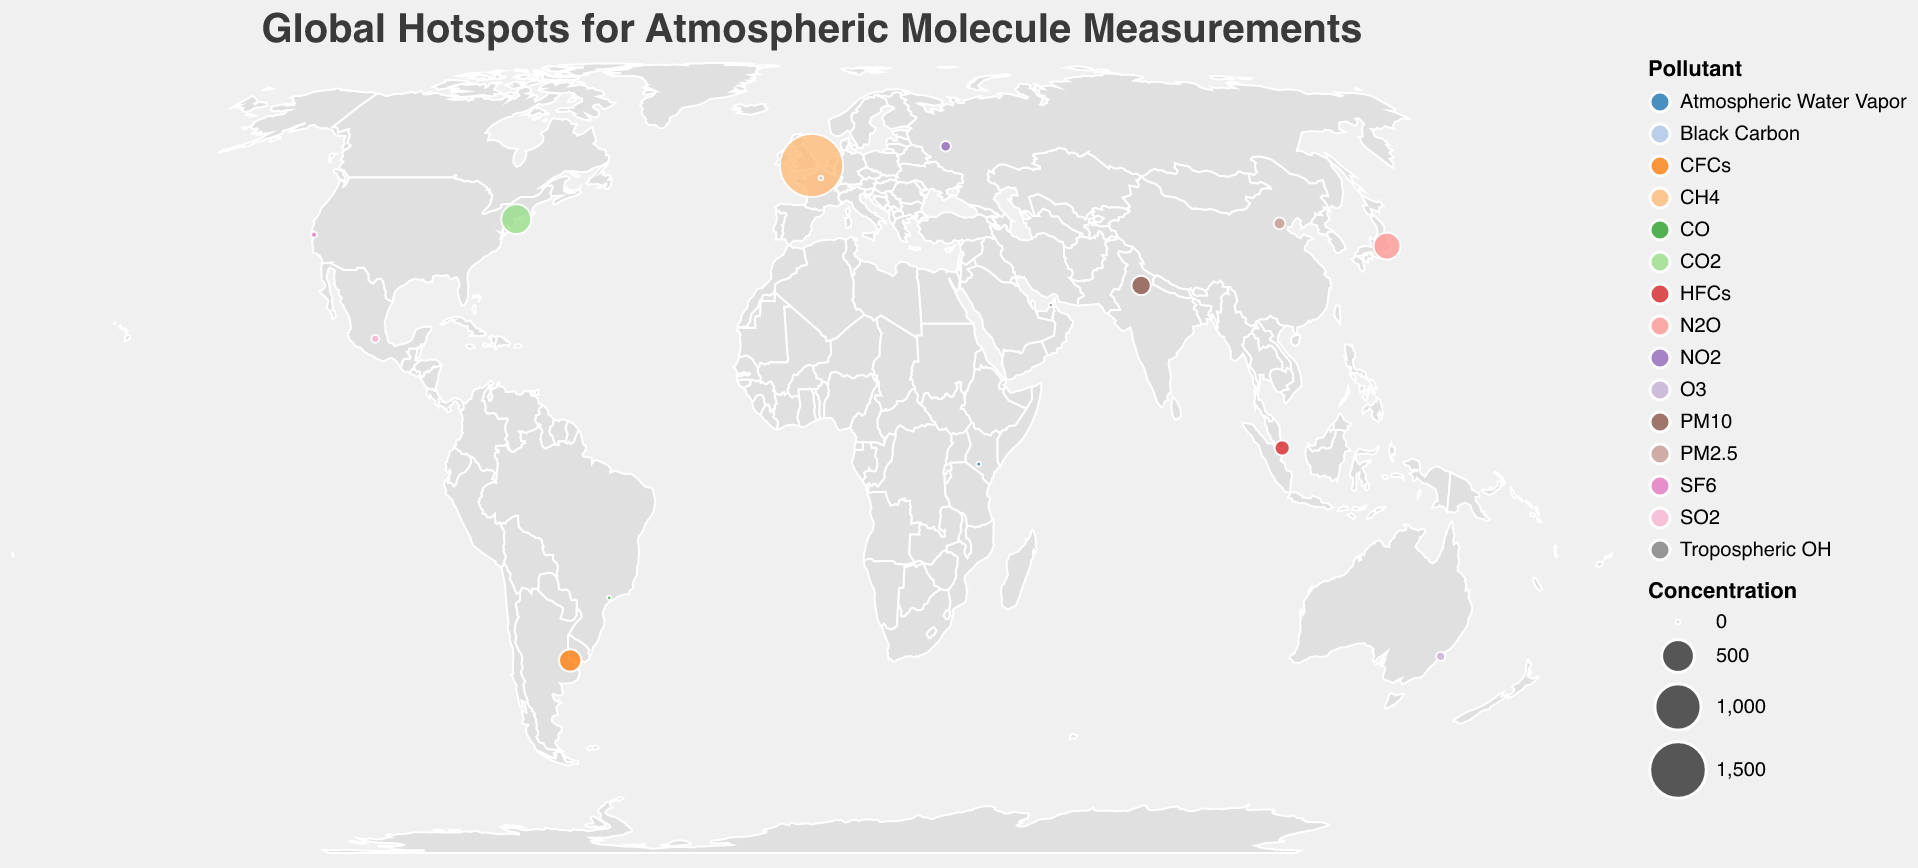What is the concentration of CO2 in New York City? Identify New York City on the map and look at the associated tooltip. The tooltip shows that the CO2 concentration is 415.2 ppm.
Answer: 415.2 ppm Which pollutant is measured in Tokyo and what is its concentration? Locate Tokyo on the map and refer to the tooltip that identifies the pollutant and its concentration. Tokyo is measuring N2O with a concentration of 332 ppb.
Answer: N2O, 332 ppb Which location has the highest concentration of PM10, and what is its value? Find the location with the highest PM10 concentration by checking the tooltips. New Delhi has the highest concentration of PM10, which is 170 µg/m³.
Answer: New Delhi, 170 µg/m³ What are the three pollutants with the lowest concentrations and their respective locations? By inspecting the tooltips, identify the three lowest pollutant concentrations: Tropospheric OH in Dubai (0.8 ppt), CO in São Paulo (1.2 ppm), and Black Carbon in Paris (2.1 µg/m³).
Answer: Tropospheric OH in Dubai, CO in São Paulo, Black Carbon in Paris What's the average concentration of pollutants measured in London and Sydney combined? Identify the concentrations for London (CH4, 1875 ppb) and Sydney (O3, 31 ppb). Convert both to the same unit if necessary, calculate the average: (1875 + 31)/2 = 953 ppb.
Answer: 953 ppb Which city has the highest concentration of a greenhouse gas, and what is that concentration? Identify greenhouse gases (CO2, CH4, N2O, SF6, CFCs, HFCs) and their concentrations in the plotted locations. London has the highest concentration of a greenhouse gas, CH4, at 1875 ppb.
Answer: London, 1875 ppb Compare the pollutants measured in New Delhi and Beijing. Which has a higher concentration and by how much? Identify the concentrations of PM10 in New Delhi (170 µg/m³) and PM2.5 in Beijing (58 µg/m³). Calculate the difference: 170 - 58 = 112 µg/m³. New Delhi has a higher concentration by 112 µg/m³.
Answer: New Delhi, 112 µg/m³ more Identify the locations measuring pollutants in parts per trillion (ppt) and list them. Refer to the tooltips to identify pollutants measured in ppt: San Francisco (SF6, 10 ppt), Buenos Aires (CFCs, 230 ppt), Singapore (HFCs, 102 ppt), Dubai (Tropospheric OH, 0.8 ppt).
Answer: San Francisco, Buenos Aires, Singapore, Dubai 